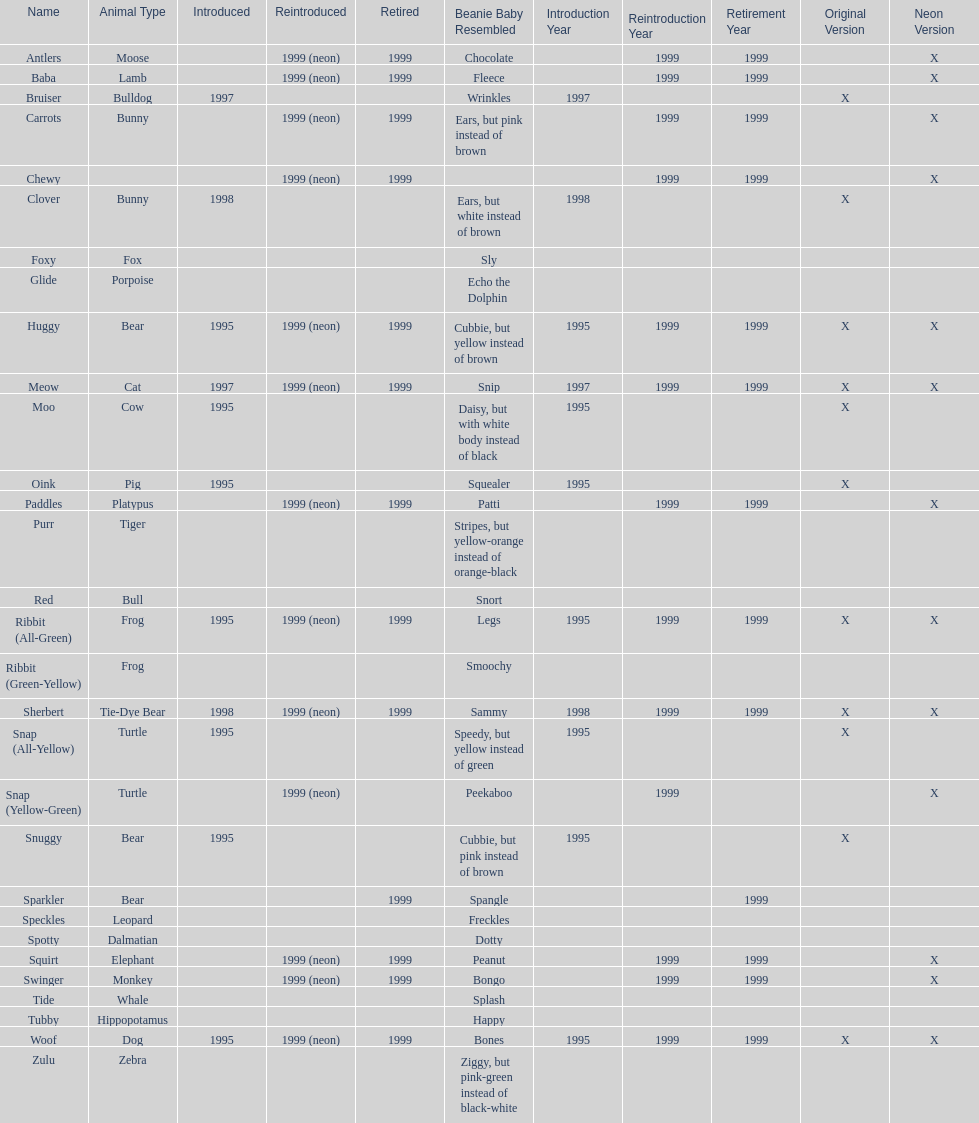Which is the only pillow pal without a listed animal type? Chewy. 